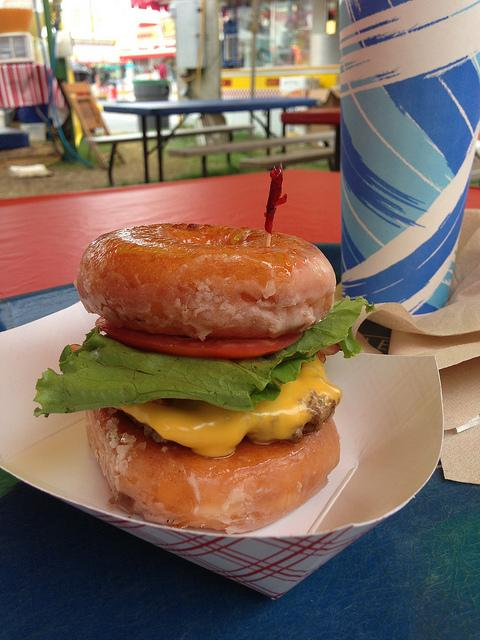What is the most unhealthy part of this cheeseburger? Please explain your reasoning. donut bun. The bun is made of donuts which are full of calories. 